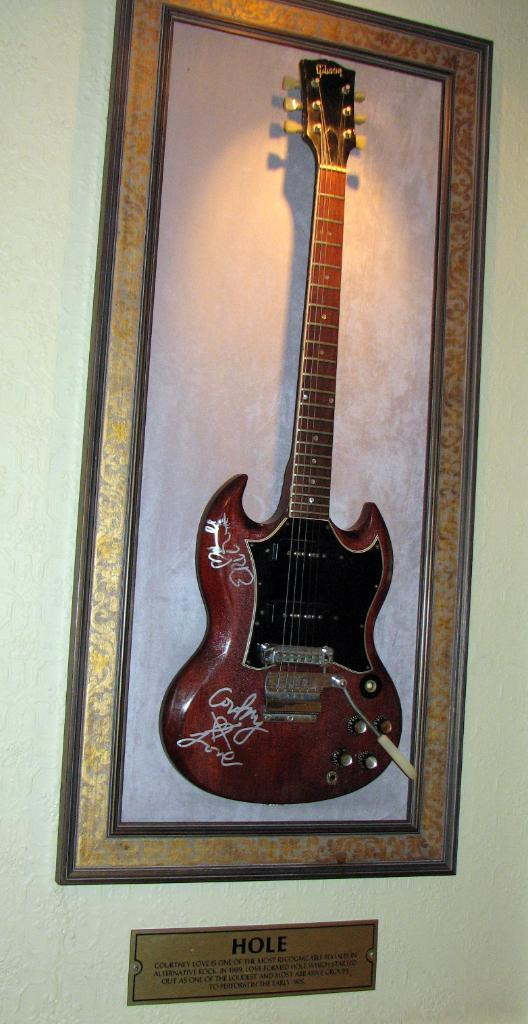What can be seen on the wall in the image? There is a frame on the wall in the image. What is located near the frame on the wall? There is a guitar near the frame on the wall. Can you describe the board with text in the image? Yes, there is a board with text in the image. What type of popcorn is being used as a decoration on the guitar in the image? There is no popcorn present in the image, and the guitar is not being used as a decoration. 